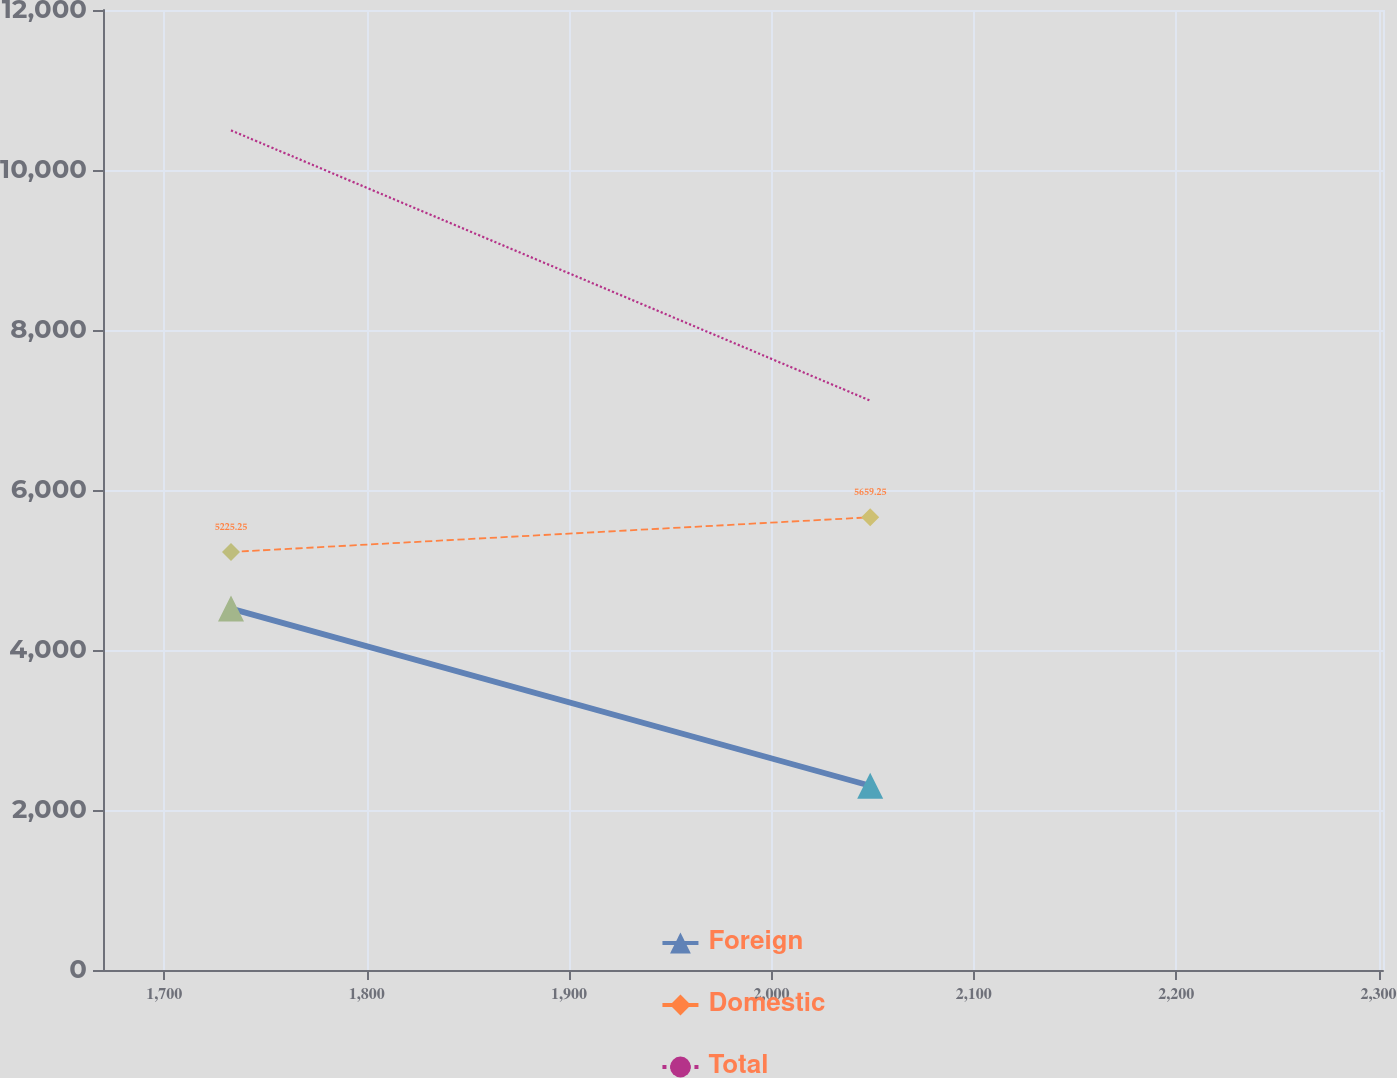<chart> <loc_0><loc_0><loc_500><loc_500><line_chart><ecel><fcel>Foreign<fcel>Domestic<fcel>Total<nl><fcel>1732.94<fcel>4517.6<fcel>5225.25<fcel>10495.4<nl><fcel>2048.81<fcel>2302.47<fcel>5659.25<fcel>7117.37<nl><fcel>2365.47<fcel>4078.6<fcel>6417.24<fcel>9254.95<nl></chart> 